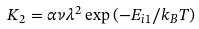<formula> <loc_0><loc_0><loc_500><loc_500>K _ { 2 } = \alpha \nu \lambda ^ { 2 } \exp \left ( - E _ { i 1 } / k _ { B } T \right )</formula> 